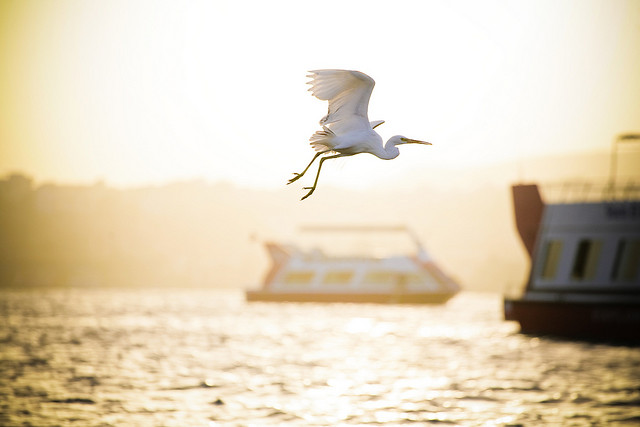If the scene were to transition into the night, how might it look? As night falls, the scene would transform into a serene and mystical setting. The water would take on a deep, reflective quality, mirroring the stars overhead like a celestial tapestry. The boats, now illuminated by soft, ambient lights, would cast gentle glows in the dark. The bird, having settled onto a perch, might be seen silhouetted against the moonlit sky, adding an element of tranquility and quiet to the scene. The once golden hues of the sunset would give way to cool blues and silvers, enveloping the river in a peaceful nighttime embrace. 